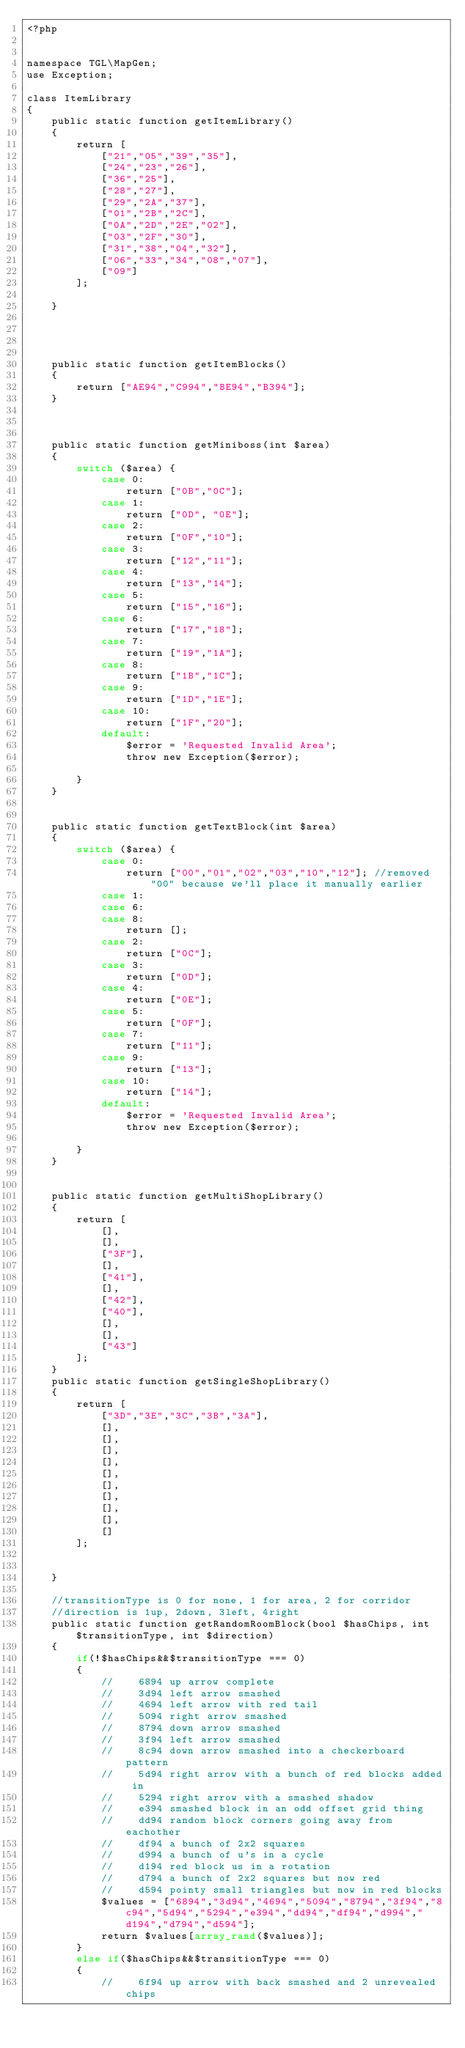<code> <loc_0><loc_0><loc_500><loc_500><_PHP_><?php


namespace TGL\MapGen;
use Exception;

class ItemLibrary
{
    public static function getItemLibrary()
    {
        return [
            ["21","05","39","35"],
            ["24","23","26"],
            ["36","25"],
            ["28","27"],
            ["29","2A","37"],
            ["01","2B","2C"],
            ["0A","2D","2E","02"],
            ["03","2F","30"],
            ["31","38","04","32"],
            ["06","33","34","08","07"],
            ["09"]
        ];

    }




    public static function getItemBlocks()
    {
        return ["AE94","C994","BE94","B394"];
    }



    public static function getMiniboss(int $area)
    {
        switch ($area) {
            case 0:
                return ["0B","0C"];
            case 1:
                return ["0D", "0E"];
            case 2:
                return ["0F","10"];
            case 3:
                return ["12","11"];
            case 4:
                return ["13","14"];
            case 5:
                return ["15","16"];
            case 6:
                return ["17","18"];
            case 7:
                return ["19","1A"];
            case 8:
                return ["1B","1C"];
            case 9:
                return ["1D","1E"];
            case 10:
                return ["1F","20"];
            default:
                $error = 'Requested Invalid Area';
                throw new Exception($error);

        }
    }


    public static function getTextBlock(int $area)
    {
        switch ($area) {
            case 0:
                return ["00","01","02","03","10","12"]; //removed "00" because we'll place it manually earlier
            case 1:
            case 6:
            case 8:
                return [];
            case 2:
                return ["0C"];
            case 3:
                return ["0D"];
            case 4:
                return ["0E"];
            case 5:
                return ["0F"];
            case 7:
                return ["11"];
            case 9:
                return ["13"];
            case 10:
                return ["14"];
            default:
                $error = 'Requested Invalid Area';
                throw new Exception($error);

        }
    }


    public static function getMultiShopLibrary()
    {
        return [
            [],
            [],
            ["3F"],
            [],
            ["41"],
            [],
            ["42"],
            ["40"],
            [],
            [],
            ["43"]
        ];
    }
    public static function getSingleShopLibrary()
    {
        return [
            ["3D","3E","3C","3B","3A"],
            [],
            [],
            [],
            [],
            [],
            [],
            [],
            [],
            [],
            []
        ];


    }

    //transitionType is 0 for none, 1 for area, 2 for corridor
    //direction is 1up, 2down, 3left, 4right
    public static function getRandomRoomBlock(bool $hasChips, int $transitionType, int $direction)
    {
        if(!$hasChips&&$transitionType === 0)
        {
            //    6894 up arrow complete
            //    3d94 left arrow smashed
            //    4694 left arrow with red tail
            //    5094 right arrow smashed
            //    8794 down arrow smashed
            //    3f94 left arrow smashed
            //    8c94 down arrow smashed into a checkerboard pattern
            //    5d94 right arrow with a bunch of red blocks added in
            //    5294 right arrow with a smashed shadow
            //    e394 smashed block in an odd offset grid thing
            //    dd94 random block corners going away from eachother
            //    df94 a bunch of 2x2 squares
            //    d994 a bunch of u's in a cycle
            //    d194 red block us in a rotation
            //    d794 a bunch of 2x2 squares but now red
            //    d594 pointy small triangles but now in red blocks
            $values = ["6894","3d94","4694","5094","8794","3f94","8c94","5d94","5294","e394","dd94","df94","d994","d194","d794","d594"];
            return $values[array_rand($values)];
        }
        else if($hasChips&&$transitionType === 0)
        {
            //    6f94 up arrow with back smashed and 2 unrevealed chips</code> 